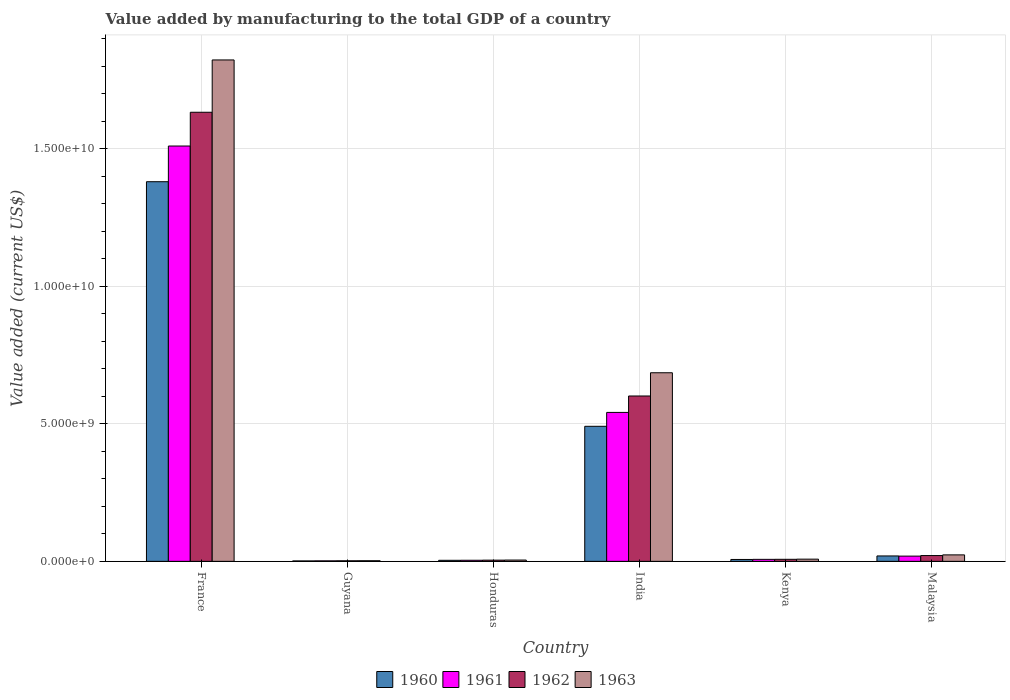Are the number of bars on each tick of the X-axis equal?
Ensure brevity in your answer.  Yes. How many bars are there on the 3rd tick from the left?
Provide a short and direct response. 4. What is the label of the 4th group of bars from the left?
Your answer should be very brief. India. In how many cases, is the number of bars for a given country not equal to the number of legend labels?
Ensure brevity in your answer.  0. What is the value added by manufacturing to the total GDP in 1963 in Guyana?
Provide a short and direct response. 2.32e+07. Across all countries, what is the maximum value added by manufacturing to the total GDP in 1963?
Provide a short and direct response. 1.82e+1. Across all countries, what is the minimum value added by manufacturing to the total GDP in 1961?
Your answer should be compact. 1.84e+07. In which country was the value added by manufacturing to the total GDP in 1960 maximum?
Make the answer very short. France. In which country was the value added by manufacturing to the total GDP in 1963 minimum?
Make the answer very short. Guyana. What is the total value added by manufacturing to the total GDP in 1960 in the graph?
Provide a succinct answer. 1.90e+1. What is the difference between the value added by manufacturing to the total GDP in 1962 in Honduras and that in India?
Give a very brief answer. -5.97e+09. What is the difference between the value added by manufacturing to the total GDP in 1962 in Kenya and the value added by manufacturing to the total GDP in 1960 in Malaysia?
Keep it short and to the point. -1.22e+08. What is the average value added by manufacturing to the total GDP in 1962 per country?
Offer a terse response. 3.78e+09. What is the difference between the value added by manufacturing to the total GDP of/in 1962 and value added by manufacturing to the total GDP of/in 1960 in Honduras?
Provide a short and direct response. 6.05e+06. In how many countries, is the value added by manufacturing to the total GDP in 1960 greater than 7000000000 US$?
Give a very brief answer. 1. What is the ratio of the value added by manufacturing to the total GDP in 1961 in Guyana to that in Kenya?
Your response must be concise. 0.25. Is the value added by manufacturing to the total GDP in 1960 in France less than that in Honduras?
Offer a terse response. No. What is the difference between the highest and the second highest value added by manufacturing to the total GDP in 1960?
Your response must be concise. 1.36e+1. What is the difference between the highest and the lowest value added by manufacturing to the total GDP in 1960?
Keep it short and to the point. 1.38e+1. Is the sum of the value added by manufacturing to the total GDP in 1960 in France and Guyana greater than the maximum value added by manufacturing to the total GDP in 1963 across all countries?
Your response must be concise. No. Is it the case that in every country, the sum of the value added by manufacturing to the total GDP in 1960 and value added by manufacturing to the total GDP in 1963 is greater than the sum of value added by manufacturing to the total GDP in 1961 and value added by manufacturing to the total GDP in 1962?
Offer a very short reply. No. What does the 1st bar from the left in France represents?
Offer a very short reply. 1960. Is it the case that in every country, the sum of the value added by manufacturing to the total GDP in 1960 and value added by manufacturing to the total GDP in 1961 is greater than the value added by manufacturing to the total GDP in 1963?
Provide a short and direct response. Yes. Are all the bars in the graph horizontal?
Offer a terse response. No. How many countries are there in the graph?
Ensure brevity in your answer.  6. Does the graph contain any zero values?
Provide a short and direct response. No. Does the graph contain grids?
Make the answer very short. Yes. How many legend labels are there?
Make the answer very short. 4. How are the legend labels stacked?
Your answer should be compact. Horizontal. What is the title of the graph?
Offer a terse response. Value added by manufacturing to the total GDP of a country. Does "2012" appear as one of the legend labels in the graph?
Offer a very short reply. No. What is the label or title of the X-axis?
Offer a very short reply. Country. What is the label or title of the Y-axis?
Keep it short and to the point. Value added (current US$). What is the Value added (current US$) of 1960 in France?
Ensure brevity in your answer.  1.38e+1. What is the Value added (current US$) in 1961 in France?
Ensure brevity in your answer.  1.51e+1. What is the Value added (current US$) in 1962 in France?
Keep it short and to the point. 1.63e+1. What is the Value added (current US$) in 1963 in France?
Ensure brevity in your answer.  1.82e+1. What is the Value added (current US$) of 1960 in Guyana?
Provide a succinct answer. 1.59e+07. What is the Value added (current US$) of 1961 in Guyana?
Offer a terse response. 1.84e+07. What is the Value added (current US$) in 1962 in Guyana?
Your response must be concise. 2.08e+07. What is the Value added (current US$) of 1963 in Guyana?
Offer a very short reply. 2.32e+07. What is the Value added (current US$) of 1960 in Honduras?
Your response must be concise. 3.80e+07. What is the Value added (current US$) of 1961 in Honduras?
Make the answer very short. 4.00e+07. What is the Value added (current US$) of 1962 in Honduras?
Provide a short and direct response. 4.41e+07. What is the Value added (current US$) of 1963 in Honduras?
Provide a succinct answer. 4.76e+07. What is the Value added (current US$) of 1960 in India?
Offer a terse response. 4.91e+09. What is the Value added (current US$) of 1961 in India?
Provide a short and direct response. 5.41e+09. What is the Value added (current US$) in 1962 in India?
Offer a terse response. 6.01e+09. What is the Value added (current US$) in 1963 in India?
Your answer should be very brief. 6.85e+09. What is the Value added (current US$) in 1960 in Kenya?
Give a very brief answer. 6.89e+07. What is the Value added (current US$) in 1961 in Kenya?
Make the answer very short. 7.28e+07. What is the Value added (current US$) in 1962 in Kenya?
Keep it short and to the point. 7.48e+07. What is the Value added (current US$) of 1963 in Kenya?
Your answer should be compact. 8.05e+07. What is the Value added (current US$) in 1960 in Malaysia?
Keep it short and to the point. 1.97e+08. What is the Value added (current US$) in 1961 in Malaysia?
Your answer should be very brief. 1.90e+08. What is the Value added (current US$) in 1962 in Malaysia?
Ensure brevity in your answer.  2.11e+08. What is the Value added (current US$) of 1963 in Malaysia?
Provide a succinct answer. 2.36e+08. Across all countries, what is the maximum Value added (current US$) in 1960?
Your answer should be compact. 1.38e+1. Across all countries, what is the maximum Value added (current US$) of 1961?
Your answer should be compact. 1.51e+1. Across all countries, what is the maximum Value added (current US$) of 1962?
Keep it short and to the point. 1.63e+1. Across all countries, what is the maximum Value added (current US$) in 1963?
Make the answer very short. 1.82e+1. Across all countries, what is the minimum Value added (current US$) in 1960?
Your answer should be compact. 1.59e+07. Across all countries, what is the minimum Value added (current US$) of 1961?
Provide a short and direct response. 1.84e+07. Across all countries, what is the minimum Value added (current US$) of 1962?
Provide a short and direct response. 2.08e+07. Across all countries, what is the minimum Value added (current US$) of 1963?
Your response must be concise. 2.32e+07. What is the total Value added (current US$) in 1960 in the graph?
Make the answer very short. 1.90e+1. What is the total Value added (current US$) of 1961 in the graph?
Provide a short and direct response. 2.08e+1. What is the total Value added (current US$) of 1962 in the graph?
Make the answer very short. 2.27e+1. What is the total Value added (current US$) of 1963 in the graph?
Give a very brief answer. 2.55e+1. What is the difference between the Value added (current US$) in 1960 in France and that in Guyana?
Make the answer very short. 1.38e+1. What is the difference between the Value added (current US$) in 1961 in France and that in Guyana?
Your answer should be compact. 1.51e+1. What is the difference between the Value added (current US$) of 1962 in France and that in Guyana?
Offer a very short reply. 1.63e+1. What is the difference between the Value added (current US$) in 1963 in France and that in Guyana?
Provide a succinct answer. 1.82e+1. What is the difference between the Value added (current US$) of 1960 in France and that in Honduras?
Your answer should be very brief. 1.38e+1. What is the difference between the Value added (current US$) in 1961 in France and that in Honduras?
Your response must be concise. 1.51e+1. What is the difference between the Value added (current US$) in 1962 in France and that in Honduras?
Ensure brevity in your answer.  1.63e+1. What is the difference between the Value added (current US$) of 1963 in France and that in Honduras?
Your response must be concise. 1.82e+1. What is the difference between the Value added (current US$) in 1960 in France and that in India?
Provide a succinct answer. 8.89e+09. What is the difference between the Value added (current US$) in 1961 in France and that in India?
Provide a succinct answer. 9.68e+09. What is the difference between the Value added (current US$) of 1962 in France and that in India?
Offer a very short reply. 1.03e+1. What is the difference between the Value added (current US$) of 1963 in France and that in India?
Provide a succinct answer. 1.14e+1. What is the difference between the Value added (current US$) of 1960 in France and that in Kenya?
Give a very brief answer. 1.37e+1. What is the difference between the Value added (current US$) of 1961 in France and that in Kenya?
Make the answer very short. 1.50e+1. What is the difference between the Value added (current US$) of 1962 in France and that in Kenya?
Give a very brief answer. 1.62e+1. What is the difference between the Value added (current US$) of 1963 in France and that in Kenya?
Make the answer very short. 1.81e+1. What is the difference between the Value added (current US$) in 1960 in France and that in Malaysia?
Provide a short and direct response. 1.36e+1. What is the difference between the Value added (current US$) in 1961 in France and that in Malaysia?
Your response must be concise. 1.49e+1. What is the difference between the Value added (current US$) in 1962 in France and that in Malaysia?
Your response must be concise. 1.61e+1. What is the difference between the Value added (current US$) of 1963 in France and that in Malaysia?
Provide a short and direct response. 1.80e+1. What is the difference between the Value added (current US$) in 1960 in Guyana and that in Honduras?
Give a very brief answer. -2.22e+07. What is the difference between the Value added (current US$) of 1961 in Guyana and that in Honduras?
Offer a very short reply. -2.17e+07. What is the difference between the Value added (current US$) in 1962 in Guyana and that in Honduras?
Offer a very short reply. -2.33e+07. What is the difference between the Value added (current US$) of 1963 in Guyana and that in Honduras?
Provide a succinct answer. -2.44e+07. What is the difference between the Value added (current US$) of 1960 in Guyana and that in India?
Offer a terse response. -4.89e+09. What is the difference between the Value added (current US$) of 1961 in Guyana and that in India?
Make the answer very short. -5.40e+09. What is the difference between the Value added (current US$) in 1962 in Guyana and that in India?
Keep it short and to the point. -5.99e+09. What is the difference between the Value added (current US$) of 1963 in Guyana and that in India?
Ensure brevity in your answer.  -6.83e+09. What is the difference between the Value added (current US$) in 1960 in Guyana and that in Kenya?
Make the answer very short. -5.30e+07. What is the difference between the Value added (current US$) in 1961 in Guyana and that in Kenya?
Give a very brief answer. -5.45e+07. What is the difference between the Value added (current US$) of 1962 in Guyana and that in Kenya?
Your answer should be compact. -5.41e+07. What is the difference between the Value added (current US$) in 1963 in Guyana and that in Kenya?
Keep it short and to the point. -5.74e+07. What is the difference between the Value added (current US$) in 1960 in Guyana and that in Malaysia?
Provide a succinct answer. -1.81e+08. What is the difference between the Value added (current US$) of 1961 in Guyana and that in Malaysia?
Your response must be concise. -1.72e+08. What is the difference between the Value added (current US$) in 1962 in Guyana and that in Malaysia?
Ensure brevity in your answer.  -1.90e+08. What is the difference between the Value added (current US$) of 1963 in Guyana and that in Malaysia?
Offer a very short reply. -2.12e+08. What is the difference between the Value added (current US$) in 1960 in Honduras and that in India?
Give a very brief answer. -4.87e+09. What is the difference between the Value added (current US$) of 1961 in Honduras and that in India?
Offer a very short reply. -5.37e+09. What is the difference between the Value added (current US$) of 1962 in Honduras and that in India?
Give a very brief answer. -5.97e+09. What is the difference between the Value added (current US$) of 1963 in Honduras and that in India?
Provide a short and direct response. -6.81e+09. What is the difference between the Value added (current US$) in 1960 in Honduras and that in Kenya?
Your answer should be very brief. -3.09e+07. What is the difference between the Value added (current US$) in 1961 in Honduras and that in Kenya?
Your answer should be very brief. -3.28e+07. What is the difference between the Value added (current US$) in 1962 in Honduras and that in Kenya?
Offer a very short reply. -3.07e+07. What is the difference between the Value added (current US$) in 1963 in Honduras and that in Kenya?
Provide a short and direct response. -3.30e+07. What is the difference between the Value added (current US$) of 1960 in Honduras and that in Malaysia?
Your answer should be very brief. -1.59e+08. What is the difference between the Value added (current US$) of 1961 in Honduras and that in Malaysia?
Give a very brief answer. -1.50e+08. What is the difference between the Value added (current US$) in 1962 in Honduras and that in Malaysia?
Ensure brevity in your answer.  -1.67e+08. What is the difference between the Value added (current US$) of 1963 in Honduras and that in Malaysia?
Your answer should be compact. -1.88e+08. What is the difference between the Value added (current US$) in 1960 in India and that in Kenya?
Ensure brevity in your answer.  4.84e+09. What is the difference between the Value added (current US$) of 1961 in India and that in Kenya?
Your response must be concise. 5.34e+09. What is the difference between the Value added (current US$) in 1962 in India and that in Kenya?
Your response must be concise. 5.94e+09. What is the difference between the Value added (current US$) of 1963 in India and that in Kenya?
Your response must be concise. 6.77e+09. What is the difference between the Value added (current US$) of 1960 in India and that in Malaysia?
Ensure brevity in your answer.  4.71e+09. What is the difference between the Value added (current US$) of 1961 in India and that in Malaysia?
Your answer should be compact. 5.22e+09. What is the difference between the Value added (current US$) in 1962 in India and that in Malaysia?
Provide a short and direct response. 5.80e+09. What is the difference between the Value added (current US$) in 1963 in India and that in Malaysia?
Provide a succinct answer. 6.62e+09. What is the difference between the Value added (current US$) of 1960 in Kenya and that in Malaysia?
Offer a terse response. -1.28e+08. What is the difference between the Value added (current US$) in 1961 in Kenya and that in Malaysia?
Offer a very short reply. -1.18e+08. What is the difference between the Value added (current US$) in 1962 in Kenya and that in Malaysia?
Keep it short and to the point. -1.36e+08. What is the difference between the Value added (current US$) of 1963 in Kenya and that in Malaysia?
Provide a short and direct response. -1.55e+08. What is the difference between the Value added (current US$) of 1960 in France and the Value added (current US$) of 1961 in Guyana?
Provide a succinct answer. 1.38e+1. What is the difference between the Value added (current US$) in 1960 in France and the Value added (current US$) in 1962 in Guyana?
Offer a very short reply. 1.38e+1. What is the difference between the Value added (current US$) in 1960 in France and the Value added (current US$) in 1963 in Guyana?
Provide a succinct answer. 1.38e+1. What is the difference between the Value added (current US$) of 1961 in France and the Value added (current US$) of 1962 in Guyana?
Offer a terse response. 1.51e+1. What is the difference between the Value added (current US$) of 1961 in France and the Value added (current US$) of 1963 in Guyana?
Offer a very short reply. 1.51e+1. What is the difference between the Value added (current US$) in 1962 in France and the Value added (current US$) in 1963 in Guyana?
Offer a terse response. 1.63e+1. What is the difference between the Value added (current US$) in 1960 in France and the Value added (current US$) in 1961 in Honduras?
Provide a short and direct response. 1.38e+1. What is the difference between the Value added (current US$) in 1960 in France and the Value added (current US$) in 1962 in Honduras?
Give a very brief answer. 1.38e+1. What is the difference between the Value added (current US$) of 1960 in France and the Value added (current US$) of 1963 in Honduras?
Your answer should be compact. 1.38e+1. What is the difference between the Value added (current US$) of 1961 in France and the Value added (current US$) of 1962 in Honduras?
Make the answer very short. 1.51e+1. What is the difference between the Value added (current US$) of 1961 in France and the Value added (current US$) of 1963 in Honduras?
Your answer should be very brief. 1.50e+1. What is the difference between the Value added (current US$) of 1962 in France and the Value added (current US$) of 1963 in Honduras?
Your answer should be compact. 1.63e+1. What is the difference between the Value added (current US$) in 1960 in France and the Value added (current US$) in 1961 in India?
Your answer should be very brief. 8.39e+09. What is the difference between the Value added (current US$) in 1960 in France and the Value added (current US$) in 1962 in India?
Your response must be concise. 7.79e+09. What is the difference between the Value added (current US$) of 1960 in France and the Value added (current US$) of 1963 in India?
Your response must be concise. 6.94e+09. What is the difference between the Value added (current US$) of 1961 in France and the Value added (current US$) of 1962 in India?
Provide a succinct answer. 9.09e+09. What is the difference between the Value added (current US$) of 1961 in France and the Value added (current US$) of 1963 in India?
Make the answer very short. 8.24e+09. What is the difference between the Value added (current US$) of 1962 in France and the Value added (current US$) of 1963 in India?
Your response must be concise. 9.47e+09. What is the difference between the Value added (current US$) of 1960 in France and the Value added (current US$) of 1961 in Kenya?
Your answer should be compact. 1.37e+1. What is the difference between the Value added (current US$) in 1960 in France and the Value added (current US$) in 1962 in Kenya?
Make the answer very short. 1.37e+1. What is the difference between the Value added (current US$) of 1960 in France and the Value added (current US$) of 1963 in Kenya?
Give a very brief answer. 1.37e+1. What is the difference between the Value added (current US$) in 1961 in France and the Value added (current US$) in 1962 in Kenya?
Make the answer very short. 1.50e+1. What is the difference between the Value added (current US$) of 1961 in France and the Value added (current US$) of 1963 in Kenya?
Offer a very short reply. 1.50e+1. What is the difference between the Value added (current US$) in 1962 in France and the Value added (current US$) in 1963 in Kenya?
Keep it short and to the point. 1.62e+1. What is the difference between the Value added (current US$) in 1960 in France and the Value added (current US$) in 1961 in Malaysia?
Provide a succinct answer. 1.36e+1. What is the difference between the Value added (current US$) in 1960 in France and the Value added (current US$) in 1962 in Malaysia?
Your response must be concise. 1.36e+1. What is the difference between the Value added (current US$) in 1960 in France and the Value added (current US$) in 1963 in Malaysia?
Offer a terse response. 1.36e+1. What is the difference between the Value added (current US$) of 1961 in France and the Value added (current US$) of 1962 in Malaysia?
Offer a very short reply. 1.49e+1. What is the difference between the Value added (current US$) of 1961 in France and the Value added (current US$) of 1963 in Malaysia?
Make the answer very short. 1.49e+1. What is the difference between the Value added (current US$) in 1962 in France and the Value added (current US$) in 1963 in Malaysia?
Offer a very short reply. 1.61e+1. What is the difference between the Value added (current US$) of 1960 in Guyana and the Value added (current US$) of 1961 in Honduras?
Ensure brevity in your answer.  -2.42e+07. What is the difference between the Value added (current US$) in 1960 in Guyana and the Value added (current US$) in 1962 in Honduras?
Your answer should be compact. -2.82e+07. What is the difference between the Value added (current US$) of 1960 in Guyana and the Value added (current US$) of 1963 in Honduras?
Your answer should be very brief. -3.17e+07. What is the difference between the Value added (current US$) of 1961 in Guyana and the Value added (current US$) of 1962 in Honduras?
Provide a succinct answer. -2.57e+07. What is the difference between the Value added (current US$) in 1961 in Guyana and the Value added (current US$) in 1963 in Honduras?
Your answer should be very brief. -2.92e+07. What is the difference between the Value added (current US$) in 1962 in Guyana and the Value added (current US$) in 1963 in Honduras?
Offer a very short reply. -2.68e+07. What is the difference between the Value added (current US$) of 1960 in Guyana and the Value added (current US$) of 1961 in India?
Keep it short and to the point. -5.40e+09. What is the difference between the Value added (current US$) of 1960 in Guyana and the Value added (current US$) of 1962 in India?
Keep it short and to the point. -5.99e+09. What is the difference between the Value added (current US$) in 1960 in Guyana and the Value added (current US$) in 1963 in India?
Offer a terse response. -6.84e+09. What is the difference between the Value added (current US$) of 1961 in Guyana and the Value added (current US$) of 1962 in India?
Your answer should be very brief. -5.99e+09. What is the difference between the Value added (current US$) in 1961 in Guyana and the Value added (current US$) in 1963 in India?
Give a very brief answer. -6.84e+09. What is the difference between the Value added (current US$) of 1962 in Guyana and the Value added (current US$) of 1963 in India?
Keep it short and to the point. -6.83e+09. What is the difference between the Value added (current US$) in 1960 in Guyana and the Value added (current US$) in 1961 in Kenya?
Your answer should be very brief. -5.70e+07. What is the difference between the Value added (current US$) in 1960 in Guyana and the Value added (current US$) in 1962 in Kenya?
Offer a terse response. -5.90e+07. What is the difference between the Value added (current US$) in 1960 in Guyana and the Value added (current US$) in 1963 in Kenya?
Ensure brevity in your answer.  -6.47e+07. What is the difference between the Value added (current US$) of 1961 in Guyana and the Value added (current US$) of 1962 in Kenya?
Make the answer very short. -5.65e+07. What is the difference between the Value added (current US$) in 1961 in Guyana and the Value added (current US$) in 1963 in Kenya?
Keep it short and to the point. -6.22e+07. What is the difference between the Value added (current US$) in 1962 in Guyana and the Value added (current US$) in 1963 in Kenya?
Give a very brief answer. -5.98e+07. What is the difference between the Value added (current US$) of 1960 in Guyana and the Value added (current US$) of 1961 in Malaysia?
Keep it short and to the point. -1.75e+08. What is the difference between the Value added (current US$) of 1960 in Guyana and the Value added (current US$) of 1962 in Malaysia?
Ensure brevity in your answer.  -1.95e+08. What is the difference between the Value added (current US$) in 1960 in Guyana and the Value added (current US$) in 1963 in Malaysia?
Offer a terse response. -2.20e+08. What is the difference between the Value added (current US$) of 1961 in Guyana and the Value added (current US$) of 1962 in Malaysia?
Your answer should be compact. -1.93e+08. What is the difference between the Value added (current US$) in 1961 in Guyana and the Value added (current US$) in 1963 in Malaysia?
Make the answer very short. -2.17e+08. What is the difference between the Value added (current US$) of 1962 in Guyana and the Value added (current US$) of 1963 in Malaysia?
Give a very brief answer. -2.15e+08. What is the difference between the Value added (current US$) of 1960 in Honduras and the Value added (current US$) of 1961 in India?
Your answer should be very brief. -5.38e+09. What is the difference between the Value added (current US$) in 1960 in Honduras and the Value added (current US$) in 1962 in India?
Provide a short and direct response. -5.97e+09. What is the difference between the Value added (current US$) in 1960 in Honduras and the Value added (current US$) in 1963 in India?
Provide a succinct answer. -6.82e+09. What is the difference between the Value added (current US$) of 1961 in Honduras and the Value added (current US$) of 1962 in India?
Make the answer very short. -5.97e+09. What is the difference between the Value added (current US$) in 1961 in Honduras and the Value added (current US$) in 1963 in India?
Ensure brevity in your answer.  -6.81e+09. What is the difference between the Value added (current US$) of 1962 in Honduras and the Value added (current US$) of 1963 in India?
Offer a very short reply. -6.81e+09. What is the difference between the Value added (current US$) in 1960 in Honduras and the Value added (current US$) in 1961 in Kenya?
Your answer should be very brief. -3.48e+07. What is the difference between the Value added (current US$) in 1960 in Honduras and the Value added (current US$) in 1962 in Kenya?
Provide a short and direct response. -3.68e+07. What is the difference between the Value added (current US$) in 1960 in Honduras and the Value added (current US$) in 1963 in Kenya?
Ensure brevity in your answer.  -4.25e+07. What is the difference between the Value added (current US$) in 1961 in Honduras and the Value added (current US$) in 1962 in Kenya?
Provide a succinct answer. -3.48e+07. What is the difference between the Value added (current US$) of 1961 in Honduras and the Value added (current US$) of 1963 in Kenya?
Provide a succinct answer. -4.05e+07. What is the difference between the Value added (current US$) of 1962 in Honduras and the Value added (current US$) of 1963 in Kenya?
Offer a terse response. -3.64e+07. What is the difference between the Value added (current US$) in 1960 in Honduras and the Value added (current US$) in 1961 in Malaysia?
Your answer should be very brief. -1.52e+08. What is the difference between the Value added (current US$) in 1960 in Honduras and the Value added (current US$) in 1962 in Malaysia?
Your response must be concise. -1.73e+08. What is the difference between the Value added (current US$) of 1960 in Honduras and the Value added (current US$) of 1963 in Malaysia?
Offer a terse response. -1.97e+08. What is the difference between the Value added (current US$) of 1961 in Honduras and the Value added (current US$) of 1962 in Malaysia?
Provide a short and direct response. -1.71e+08. What is the difference between the Value added (current US$) of 1961 in Honduras and the Value added (current US$) of 1963 in Malaysia?
Give a very brief answer. -1.95e+08. What is the difference between the Value added (current US$) in 1962 in Honduras and the Value added (current US$) in 1963 in Malaysia?
Ensure brevity in your answer.  -1.91e+08. What is the difference between the Value added (current US$) of 1960 in India and the Value added (current US$) of 1961 in Kenya?
Your response must be concise. 4.84e+09. What is the difference between the Value added (current US$) of 1960 in India and the Value added (current US$) of 1962 in Kenya?
Offer a very short reply. 4.83e+09. What is the difference between the Value added (current US$) in 1960 in India and the Value added (current US$) in 1963 in Kenya?
Provide a short and direct response. 4.83e+09. What is the difference between the Value added (current US$) in 1961 in India and the Value added (current US$) in 1962 in Kenya?
Ensure brevity in your answer.  5.34e+09. What is the difference between the Value added (current US$) in 1961 in India and the Value added (current US$) in 1963 in Kenya?
Keep it short and to the point. 5.33e+09. What is the difference between the Value added (current US$) in 1962 in India and the Value added (current US$) in 1963 in Kenya?
Your answer should be very brief. 5.93e+09. What is the difference between the Value added (current US$) in 1960 in India and the Value added (current US$) in 1961 in Malaysia?
Offer a very short reply. 4.72e+09. What is the difference between the Value added (current US$) in 1960 in India and the Value added (current US$) in 1962 in Malaysia?
Provide a succinct answer. 4.70e+09. What is the difference between the Value added (current US$) of 1960 in India and the Value added (current US$) of 1963 in Malaysia?
Ensure brevity in your answer.  4.67e+09. What is the difference between the Value added (current US$) in 1961 in India and the Value added (current US$) in 1962 in Malaysia?
Provide a succinct answer. 5.20e+09. What is the difference between the Value added (current US$) of 1961 in India and the Value added (current US$) of 1963 in Malaysia?
Give a very brief answer. 5.18e+09. What is the difference between the Value added (current US$) of 1962 in India and the Value added (current US$) of 1963 in Malaysia?
Your answer should be compact. 5.78e+09. What is the difference between the Value added (current US$) in 1960 in Kenya and the Value added (current US$) in 1961 in Malaysia?
Your answer should be compact. -1.21e+08. What is the difference between the Value added (current US$) in 1960 in Kenya and the Value added (current US$) in 1962 in Malaysia?
Offer a very short reply. -1.42e+08. What is the difference between the Value added (current US$) in 1960 in Kenya and the Value added (current US$) in 1963 in Malaysia?
Offer a terse response. -1.67e+08. What is the difference between the Value added (current US$) of 1961 in Kenya and the Value added (current US$) of 1962 in Malaysia?
Your response must be concise. -1.38e+08. What is the difference between the Value added (current US$) in 1961 in Kenya and the Value added (current US$) in 1963 in Malaysia?
Your response must be concise. -1.63e+08. What is the difference between the Value added (current US$) of 1962 in Kenya and the Value added (current US$) of 1963 in Malaysia?
Offer a terse response. -1.61e+08. What is the average Value added (current US$) in 1960 per country?
Your answer should be very brief. 3.17e+09. What is the average Value added (current US$) of 1961 per country?
Your answer should be very brief. 3.47e+09. What is the average Value added (current US$) in 1962 per country?
Provide a short and direct response. 3.78e+09. What is the average Value added (current US$) of 1963 per country?
Provide a short and direct response. 4.24e+09. What is the difference between the Value added (current US$) of 1960 and Value added (current US$) of 1961 in France?
Provide a succinct answer. -1.30e+09. What is the difference between the Value added (current US$) of 1960 and Value added (current US$) of 1962 in France?
Your answer should be compact. -2.52e+09. What is the difference between the Value added (current US$) in 1960 and Value added (current US$) in 1963 in France?
Provide a succinct answer. -4.43e+09. What is the difference between the Value added (current US$) of 1961 and Value added (current US$) of 1962 in France?
Provide a short and direct response. -1.23e+09. What is the difference between the Value added (current US$) in 1961 and Value added (current US$) in 1963 in France?
Offer a terse response. -3.13e+09. What is the difference between the Value added (current US$) of 1962 and Value added (current US$) of 1963 in France?
Keep it short and to the point. -1.90e+09. What is the difference between the Value added (current US$) in 1960 and Value added (current US$) in 1961 in Guyana?
Offer a very short reply. -2.51e+06. What is the difference between the Value added (current US$) in 1960 and Value added (current US$) in 1962 in Guyana?
Provide a short and direct response. -4.90e+06. What is the difference between the Value added (current US$) of 1960 and Value added (current US$) of 1963 in Guyana?
Offer a terse response. -7.29e+06. What is the difference between the Value added (current US$) of 1961 and Value added (current US$) of 1962 in Guyana?
Offer a terse response. -2.39e+06. What is the difference between the Value added (current US$) of 1961 and Value added (current US$) of 1963 in Guyana?
Offer a terse response. -4.78e+06. What is the difference between the Value added (current US$) of 1962 and Value added (current US$) of 1963 in Guyana?
Keep it short and to the point. -2.39e+06. What is the difference between the Value added (current US$) in 1960 and Value added (current US$) in 1961 in Honduras?
Provide a short and direct response. -2.00e+06. What is the difference between the Value added (current US$) in 1960 and Value added (current US$) in 1962 in Honduras?
Your response must be concise. -6.05e+06. What is the difference between the Value added (current US$) in 1960 and Value added (current US$) in 1963 in Honduras?
Make the answer very short. -9.50e+06. What is the difference between the Value added (current US$) of 1961 and Value added (current US$) of 1962 in Honduras?
Keep it short and to the point. -4.05e+06. What is the difference between the Value added (current US$) in 1961 and Value added (current US$) in 1963 in Honduras?
Give a very brief answer. -7.50e+06. What is the difference between the Value added (current US$) in 1962 and Value added (current US$) in 1963 in Honduras?
Offer a terse response. -3.45e+06. What is the difference between the Value added (current US$) in 1960 and Value added (current US$) in 1961 in India?
Ensure brevity in your answer.  -5.05e+08. What is the difference between the Value added (current US$) of 1960 and Value added (current US$) of 1962 in India?
Offer a very short reply. -1.10e+09. What is the difference between the Value added (current US$) of 1960 and Value added (current US$) of 1963 in India?
Ensure brevity in your answer.  -1.95e+09. What is the difference between the Value added (current US$) in 1961 and Value added (current US$) in 1962 in India?
Your response must be concise. -5.97e+08. What is the difference between the Value added (current US$) of 1961 and Value added (current US$) of 1963 in India?
Provide a short and direct response. -1.44e+09. What is the difference between the Value added (current US$) in 1962 and Value added (current US$) in 1963 in India?
Ensure brevity in your answer.  -8.44e+08. What is the difference between the Value added (current US$) in 1960 and Value added (current US$) in 1961 in Kenya?
Your response must be concise. -3.93e+06. What is the difference between the Value added (current US$) in 1960 and Value added (current US$) in 1962 in Kenya?
Offer a very short reply. -5.94e+06. What is the difference between the Value added (current US$) of 1960 and Value added (current US$) of 1963 in Kenya?
Your answer should be compact. -1.16e+07. What is the difference between the Value added (current US$) in 1961 and Value added (current US$) in 1962 in Kenya?
Make the answer very short. -2.00e+06. What is the difference between the Value added (current US$) of 1961 and Value added (current US$) of 1963 in Kenya?
Provide a succinct answer. -7.70e+06. What is the difference between the Value added (current US$) of 1962 and Value added (current US$) of 1963 in Kenya?
Offer a very short reply. -5.70e+06. What is the difference between the Value added (current US$) of 1960 and Value added (current US$) of 1961 in Malaysia?
Provide a short and direct response. 6.25e+06. What is the difference between the Value added (current US$) in 1960 and Value added (current US$) in 1962 in Malaysia?
Your response must be concise. -1.46e+07. What is the difference between the Value added (current US$) of 1960 and Value added (current US$) of 1963 in Malaysia?
Give a very brief answer. -3.89e+07. What is the difference between the Value added (current US$) in 1961 and Value added (current US$) in 1962 in Malaysia?
Your answer should be compact. -2.08e+07. What is the difference between the Value added (current US$) in 1961 and Value added (current US$) in 1963 in Malaysia?
Ensure brevity in your answer.  -4.52e+07. What is the difference between the Value added (current US$) of 1962 and Value added (current US$) of 1963 in Malaysia?
Keep it short and to the point. -2.43e+07. What is the ratio of the Value added (current US$) of 1960 in France to that in Guyana?
Your response must be concise. 869.7. What is the ratio of the Value added (current US$) of 1961 in France to that in Guyana?
Ensure brevity in your answer.  821.55. What is the ratio of the Value added (current US$) in 1962 in France to that in Guyana?
Your answer should be compact. 786.05. What is the ratio of the Value added (current US$) of 1963 in France to that in Guyana?
Ensure brevity in your answer.  786.97. What is the ratio of the Value added (current US$) in 1960 in France to that in Honduras?
Make the answer very short. 362.66. What is the ratio of the Value added (current US$) of 1961 in France to that in Honduras?
Give a very brief answer. 376.93. What is the ratio of the Value added (current US$) of 1962 in France to that in Honduras?
Provide a succinct answer. 370.15. What is the ratio of the Value added (current US$) in 1963 in France to that in Honduras?
Your answer should be very brief. 383.28. What is the ratio of the Value added (current US$) of 1960 in France to that in India?
Your answer should be compact. 2.81. What is the ratio of the Value added (current US$) in 1961 in France to that in India?
Your answer should be compact. 2.79. What is the ratio of the Value added (current US$) in 1962 in France to that in India?
Provide a succinct answer. 2.72. What is the ratio of the Value added (current US$) of 1963 in France to that in India?
Provide a short and direct response. 2.66. What is the ratio of the Value added (current US$) in 1960 in France to that in Kenya?
Your response must be concise. 200.26. What is the ratio of the Value added (current US$) in 1961 in France to that in Kenya?
Offer a terse response. 207.24. What is the ratio of the Value added (current US$) of 1962 in France to that in Kenya?
Give a very brief answer. 218.1. What is the ratio of the Value added (current US$) in 1963 in France to that in Kenya?
Provide a succinct answer. 226.28. What is the ratio of the Value added (current US$) of 1960 in France to that in Malaysia?
Provide a succinct answer. 70.18. What is the ratio of the Value added (current US$) in 1961 in France to that in Malaysia?
Your answer should be very brief. 79.3. What is the ratio of the Value added (current US$) in 1962 in France to that in Malaysia?
Offer a very short reply. 77.29. What is the ratio of the Value added (current US$) of 1963 in France to that in Malaysia?
Provide a short and direct response. 77.38. What is the ratio of the Value added (current US$) in 1960 in Guyana to that in Honduras?
Give a very brief answer. 0.42. What is the ratio of the Value added (current US$) in 1961 in Guyana to that in Honduras?
Provide a short and direct response. 0.46. What is the ratio of the Value added (current US$) in 1962 in Guyana to that in Honduras?
Make the answer very short. 0.47. What is the ratio of the Value added (current US$) of 1963 in Guyana to that in Honduras?
Give a very brief answer. 0.49. What is the ratio of the Value added (current US$) of 1960 in Guyana to that in India?
Give a very brief answer. 0. What is the ratio of the Value added (current US$) of 1961 in Guyana to that in India?
Provide a short and direct response. 0. What is the ratio of the Value added (current US$) of 1962 in Guyana to that in India?
Provide a succinct answer. 0. What is the ratio of the Value added (current US$) of 1963 in Guyana to that in India?
Your answer should be compact. 0. What is the ratio of the Value added (current US$) in 1960 in Guyana to that in Kenya?
Your response must be concise. 0.23. What is the ratio of the Value added (current US$) of 1961 in Guyana to that in Kenya?
Your response must be concise. 0.25. What is the ratio of the Value added (current US$) of 1962 in Guyana to that in Kenya?
Keep it short and to the point. 0.28. What is the ratio of the Value added (current US$) in 1963 in Guyana to that in Kenya?
Your answer should be very brief. 0.29. What is the ratio of the Value added (current US$) in 1960 in Guyana to that in Malaysia?
Your answer should be compact. 0.08. What is the ratio of the Value added (current US$) in 1961 in Guyana to that in Malaysia?
Provide a succinct answer. 0.1. What is the ratio of the Value added (current US$) in 1962 in Guyana to that in Malaysia?
Keep it short and to the point. 0.1. What is the ratio of the Value added (current US$) in 1963 in Guyana to that in Malaysia?
Ensure brevity in your answer.  0.1. What is the ratio of the Value added (current US$) in 1960 in Honduras to that in India?
Your answer should be very brief. 0.01. What is the ratio of the Value added (current US$) in 1961 in Honduras to that in India?
Offer a terse response. 0.01. What is the ratio of the Value added (current US$) in 1962 in Honduras to that in India?
Offer a very short reply. 0.01. What is the ratio of the Value added (current US$) of 1963 in Honduras to that in India?
Keep it short and to the point. 0.01. What is the ratio of the Value added (current US$) of 1960 in Honduras to that in Kenya?
Provide a short and direct response. 0.55. What is the ratio of the Value added (current US$) in 1961 in Honduras to that in Kenya?
Provide a succinct answer. 0.55. What is the ratio of the Value added (current US$) of 1962 in Honduras to that in Kenya?
Provide a succinct answer. 0.59. What is the ratio of the Value added (current US$) in 1963 in Honduras to that in Kenya?
Your response must be concise. 0.59. What is the ratio of the Value added (current US$) of 1960 in Honduras to that in Malaysia?
Your answer should be very brief. 0.19. What is the ratio of the Value added (current US$) of 1961 in Honduras to that in Malaysia?
Keep it short and to the point. 0.21. What is the ratio of the Value added (current US$) of 1962 in Honduras to that in Malaysia?
Ensure brevity in your answer.  0.21. What is the ratio of the Value added (current US$) in 1963 in Honduras to that in Malaysia?
Make the answer very short. 0.2. What is the ratio of the Value added (current US$) in 1960 in India to that in Kenya?
Give a very brief answer. 71.24. What is the ratio of the Value added (current US$) in 1961 in India to that in Kenya?
Ensure brevity in your answer.  74.32. What is the ratio of the Value added (current US$) of 1962 in India to that in Kenya?
Keep it short and to the point. 80.31. What is the ratio of the Value added (current US$) in 1963 in India to that in Kenya?
Ensure brevity in your answer.  85.11. What is the ratio of the Value added (current US$) in 1960 in India to that in Malaysia?
Make the answer very short. 24.96. What is the ratio of the Value added (current US$) in 1961 in India to that in Malaysia?
Ensure brevity in your answer.  28.44. What is the ratio of the Value added (current US$) of 1962 in India to that in Malaysia?
Make the answer very short. 28.46. What is the ratio of the Value added (current US$) of 1963 in India to that in Malaysia?
Your response must be concise. 29.1. What is the ratio of the Value added (current US$) of 1960 in Kenya to that in Malaysia?
Keep it short and to the point. 0.35. What is the ratio of the Value added (current US$) of 1961 in Kenya to that in Malaysia?
Provide a succinct answer. 0.38. What is the ratio of the Value added (current US$) in 1962 in Kenya to that in Malaysia?
Give a very brief answer. 0.35. What is the ratio of the Value added (current US$) in 1963 in Kenya to that in Malaysia?
Provide a succinct answer. 0.34. What is the difference between the highest and the second highest Value added (current US$) in 1960?
Give a very brief answer. 8.89e+09. What is the difference between the highest and the second highest Value added (current US$) in 1961?
Your response must be concise. 9.68e+09. What is the difference between the highest and the second highest Value added (current US$) of 1962?
Offer a terse response. 1.03e+1. What is the difference between the highest and the second highest Value added (current US$) of 1963?
Your answer should be compact. 1.14e+1. What is the difference between the highest and the lowest Value added (current US$) in 1960?
Your answer should be very brief. 1.38e+1. What is the difference between the highest and the lowest Value added (current US$) in 1961?
Provide a short and direct response. 1.51e+1. What is the difference between the highest and the lowest Value added (current US$) of 1962?
Offer a terse response. 1.63e+1. What is the difference between the highest and the lowest Value added (current US$) in 1963?
Provide a short and direct response. 1.82e+1. 